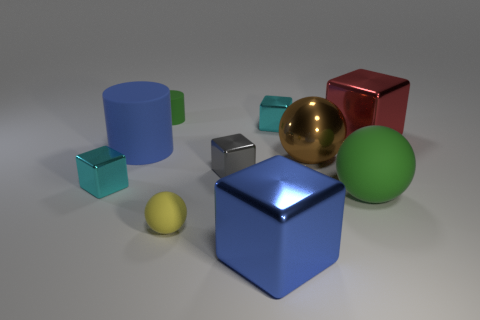Are there any red metal things?
Provide a short and direct response. Yes. What is the material of the green thing on the left side of the sphere to the left of the big blue object that is in front of the brown shiny sphere?
Keep it short and to the point. Rubber. There is a large green rubber thing; is its shape the same as the big metal object behind the large rubber cylinder?
Provide a short and direct response. No. How many large green rubber things are the same shape as the gray shiny object?
Your answer should be compact. 0. There is a big brown object; what shape is it?
Offer a terse response. Sphere. There is a blue thing that is in front of the blue thing to the left of the tiny cylinder; how big is it?
Offer a very short reply. Large. What number of objects are either blue metallic cubes or red metallic cubes?
Provide a succinct answer. 2. Is the shape of the tiny gray shiny thing the same as the large brown object?
Provide a succinct answer. No. Is there a big red block made of the same material as the small cylinder?
Offer a terse response. No. There is a big blue thing behind the large green object; is there a cylinder behind it?
Offer a very short reply. Yes. 